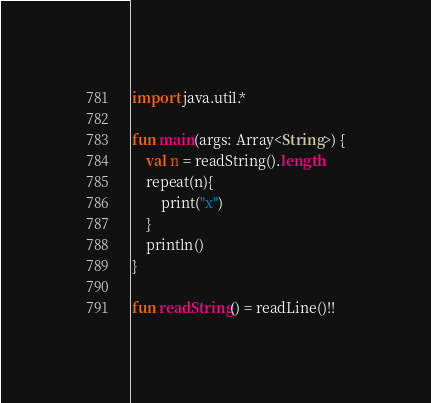Convert code to text. <code><loc_0><loc_0><loc_500><loc_500><_Kotlin_>import java.util.*

fun main(args: Array<String>) {
    val n = readString().length
    repeat(n){
        print("x")
    }
    println()
}

fun readString() = readLine()!!</code> 